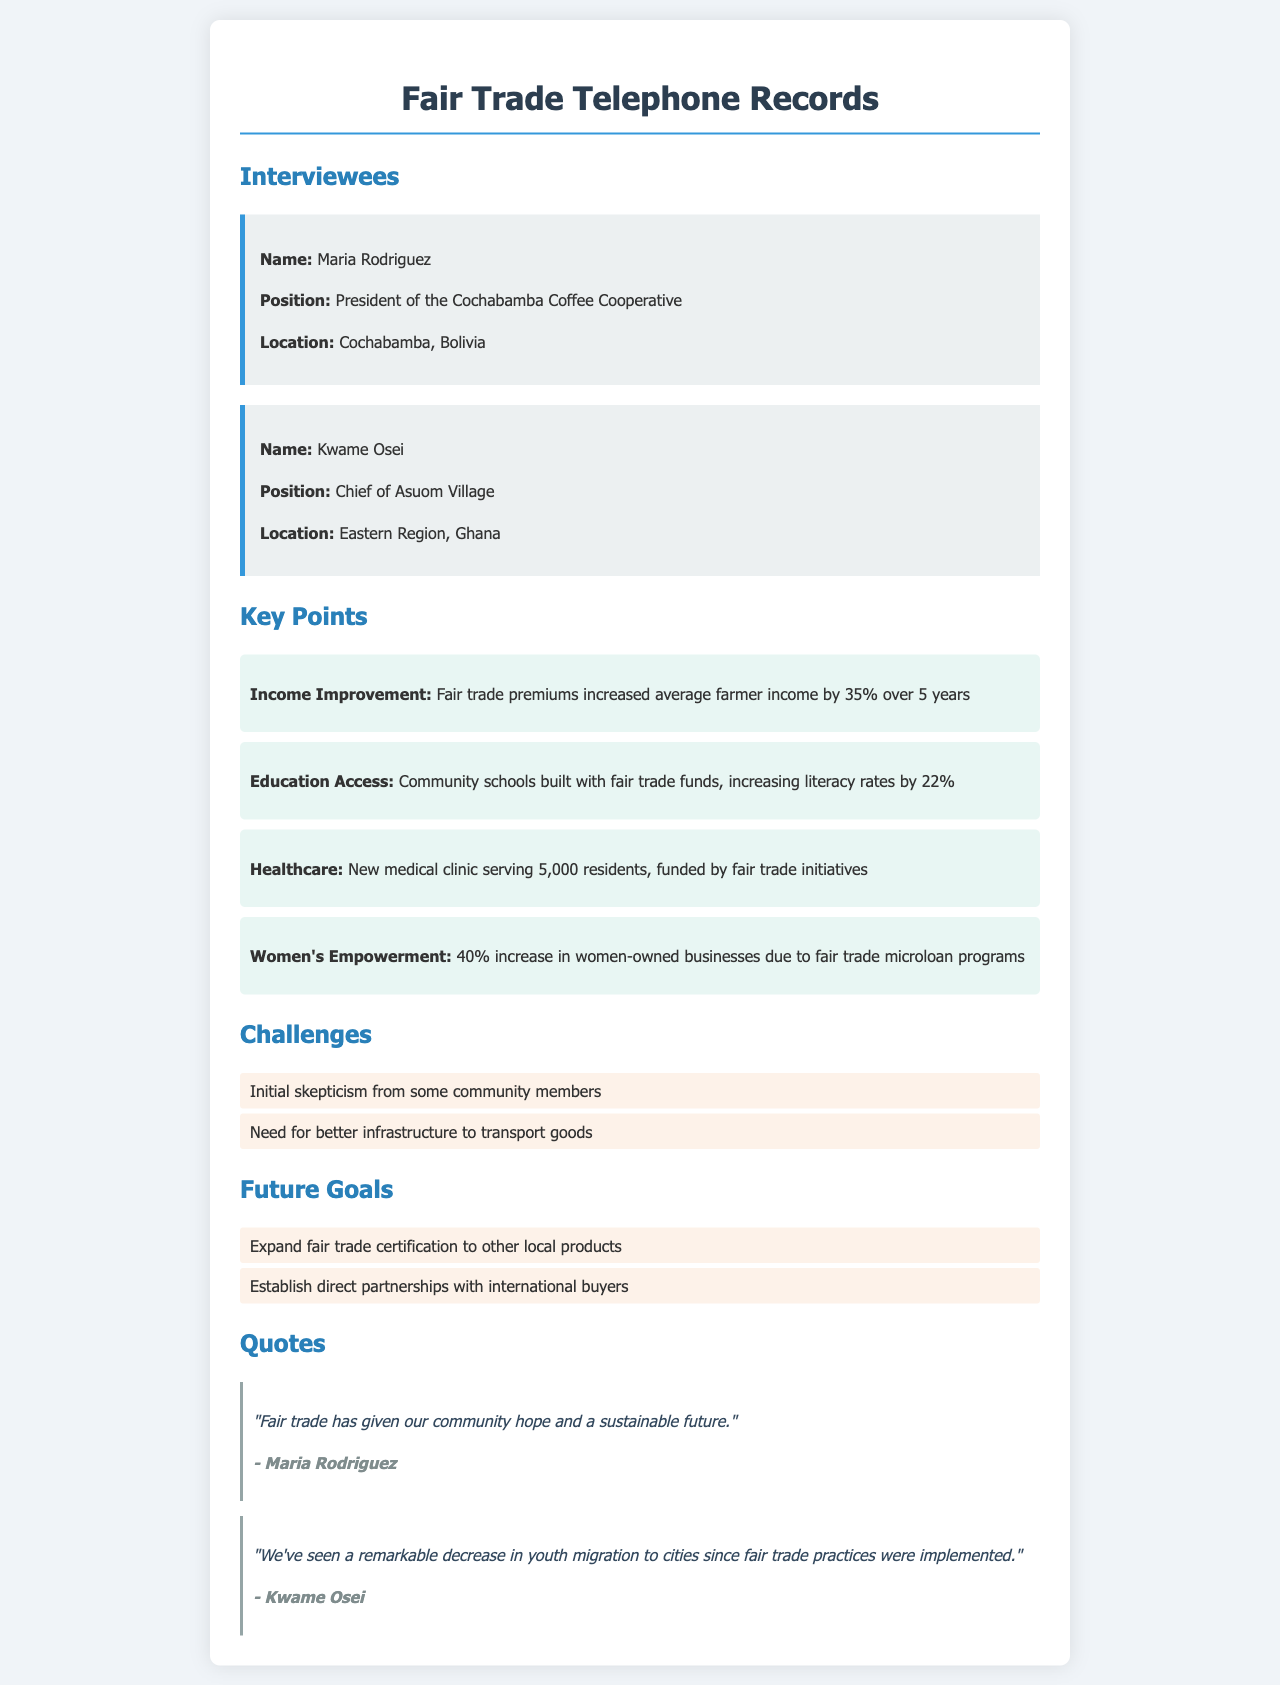what is the name of the president of the Cochabamba Coffee Cooperative? The document states that the president of the Cochabamba Coffee Cooperative is Maria Rodriguez.
Answer: Maria Rodriguez what is the average percentage increase in farmer income due to fair trade premiums? The document mentions that fair trade premiums increased average farmer income by 35%.
Answer: 35% how many residents does the new medical clinic serve? The document indicates that the new medical clinic serves 5,000 residents.
Answer: 5,000 what is a key challenge mentioned in the document? The document lists initial skepticism from some community members as one of the challenges faced.
Answer: Initial skepticism from some community members what future goal is related to direct partnerships? The document outlines a future goal to establish direct partnerships with international buyers.
Answer: Establish direct partnerships with international buyers what notable effect has fair trade had on youth migration according to Kwame Osei? The document quotes Kwame Osei stating that there has been a remarkable decrease in youth migration to cities due to fair trade practices.
Answer: Remarkable decrease in youth migration how many women-owned businesses have increased due to fair trade microloan programs? The document states there has been a 40% increase in women-owned businesses due to these programs.
Answer: 40% what has been built with fair trade funds to improve community education? The document mentions that community schools have been built with fair trade funds.
Answer: Community schools who is the chief of Asuom Village? The document identifies Kwame Osei as the chief of Asuom Village.
Answer: Kwame Osei 